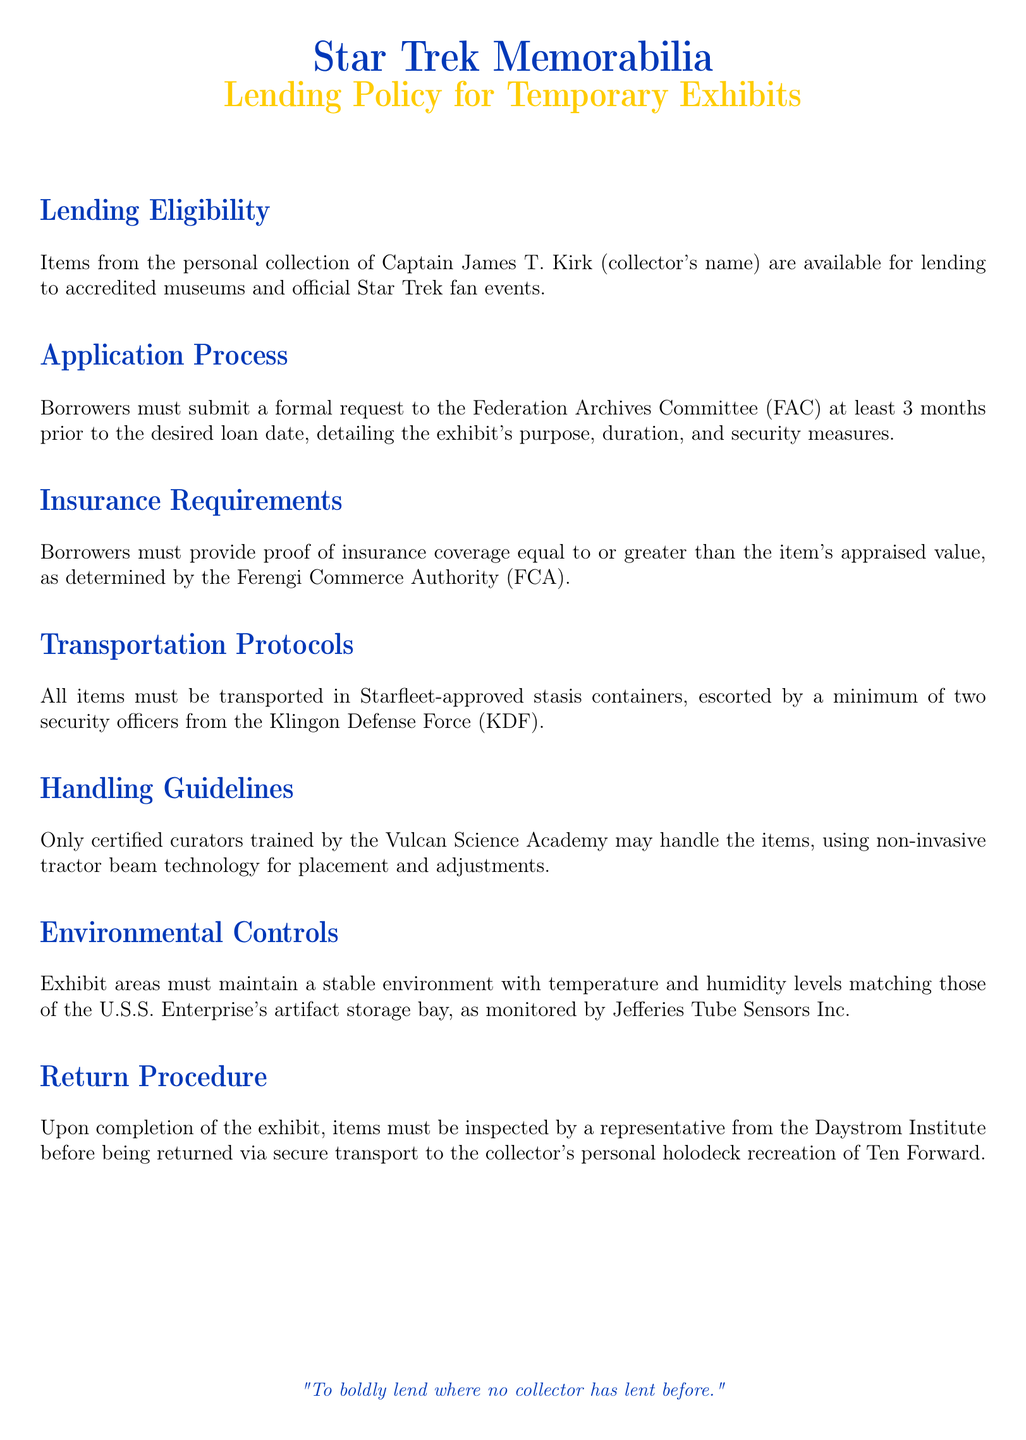What is the title of the policy document? The title is clearly stated at the beginning of the document, which is "Lending Policy for Temporary Exhibits."
Answer: Lending Policy for Temporary Exhibits Who are the items available for lending from? The document specifies that items are from the personal collection of Captain James T. Kirk.
Answer: Captain James T. Kirk How many months prior to the loan date must the request be submitted? The application process section stipulates that requests must be submitted at least 3 months in advance.
Answer: 3 months What must borrowers provide for insurance? The policy states that borrowers must provide proof of insurance coverage equal to or greater than the item's appraised value.
Answer: Proof of insurance Who must handle the items? The handling guidelines specify that only certified curators trained by the Vulcan Science Academy may handle the items.
Answer: Certified curators What type of containers must be used for transportation? The document indicates that items must be transported in Starfleet-approved stasis containers.
Answer: Starfleet-approved stasis containers What is the required escort during transportation? The transportation protocols specify that items must be escorted by a minimum of two security officers from the Klingon Defense Force.
Answer: Two security officers What needs to be inspected before returning items? The return procedure states that items must be inspected by a representative from the Daystrom Institute.
Answer: Daystrom Institute What company monitors the environmental controls? The document mentions that Jefferies Tube Sensors Inc. is responsible for monitoring the environmental controls.
Answer: Jefferies Tube Sensors Inc 